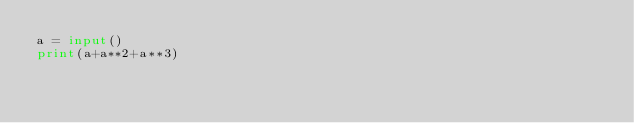<code> <loc_0><loc_0><loc_500><loc_500><_Python_>a = input()
print(a+a**2+a**3)</code> 